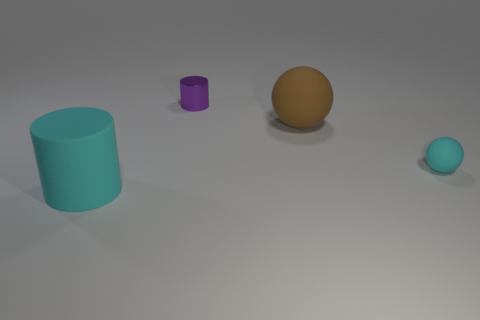What number of large objects are on the left side of the cylinder right of the cyan cylinder?
Give a very brief answer. 1. What number of small rubber things are the same shape as the large brown object?
Offer a terse response. 1. What number of small matte spheres are there?
Provide a short and direct response. 1. There is a rubber thing left of the tiny cylinder; what is its color?
Your answer should be very brief. Cyan. What is the color of the cylinder in front of the matte sphere to the left of the cyan ball?
Offer a very short reply. Cyan. There is a sphere that is the same size as the matte cylinder; what color is it?
Your response must be concise. Brown. What number of matte objects are left of the cyan rubber sphere and behind the large cylinder?
Offer a terse response. 1. What shape is the tiny rubber thing that is the same color as the big rubber cylinder?
Offer a very short reply. Sphere. What material is the object that is both behind the tiny cyan matte thing and to the right of the small cylinder?
Ensure brevity in your answer.  Rubber. Are there fewer large spheres right of the cyan rubber sphere than big balls that are in front of the brown rubber sphere?
Keep it short and to the point. No. 